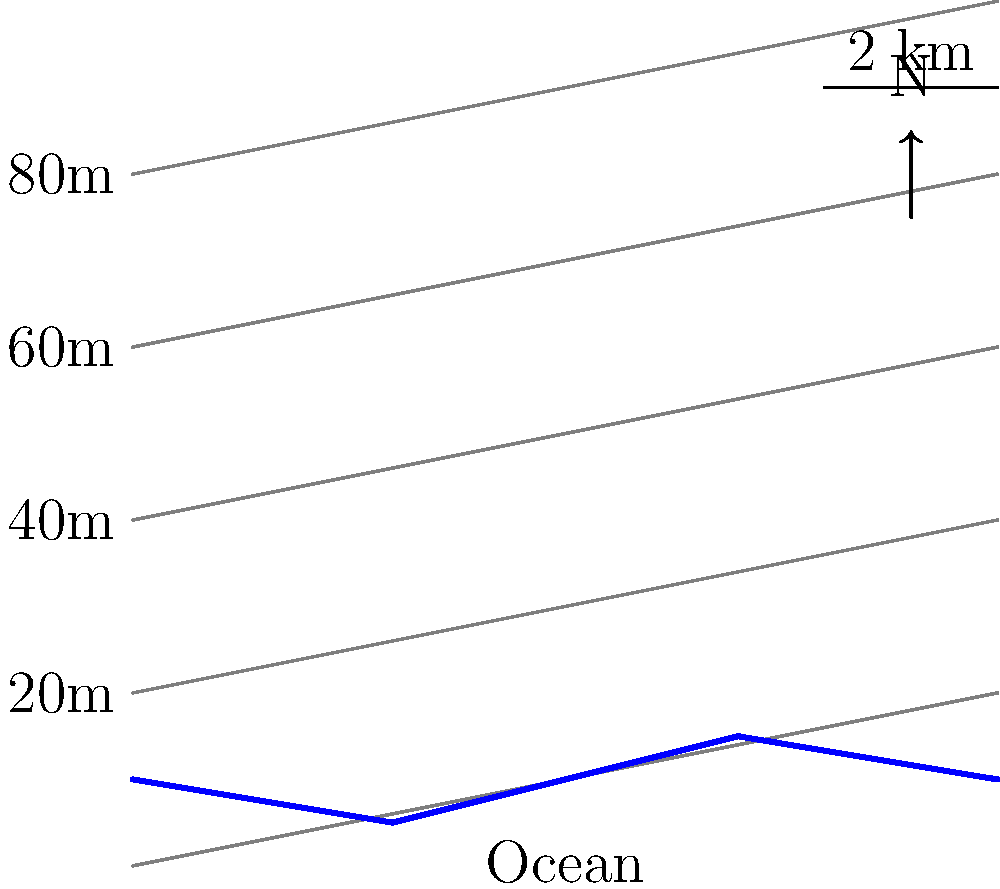Based on the topographic map of a coastal area in KwaZulu-Natal, which region is most susceptible to flooding during a storm surge event that raises sea level by 5 meters? To determine the area most susceptible to flooding during a 5-meter storm surge, we need to follow these steps:

1. Understand the contour lines: Each contour line represents a specific elevation above sea level. In this map, the contour intervals are 20 meters apart.

2. Identify the 20-meter contour line: This is the first line above the coastline, labeled "20m" on the left side of the map.

3. Estimate the 5-meter elevation: Since the contour interval is 20 meters, the 5-meter elevation would be approximately 1/4 of the distance between the coastline and the 20-meter contour line.

4. Analyze the coastline: Look for areas where the distance between the coastline and the 20-meter contour line is smallest. These areas have the steepest slope and are less susceptible to flooding.

5. Identify vulnerable areas: Look for regions where the distance between the coastline and the 20-meter contour line is largest. These areas have a gentler slope and are more susceptible to flooding.

6. Compare coastal regions: The central part of the coastline (around x-coordinate 5) has the greatest distance between the coast and the 20-meter contour line. This indicates a gentler slope and a larger low-lying area.

Therefore, the central region of the coastline, approximately around the x-coordinate 5, is most susceptible to flooding during a 5-meter storm surge event.
Answer: Central coastal region 